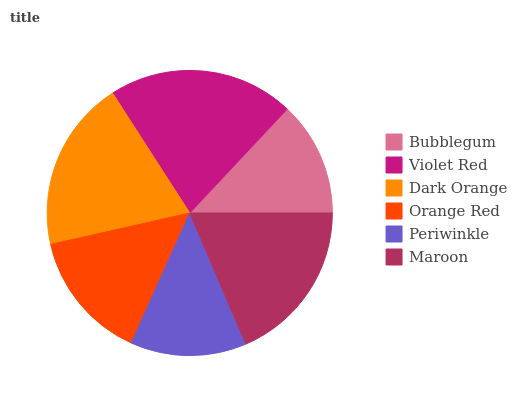Is Bubblegum the minimum?
Answer yes or no. Yes. Is Violet Red the maximum?
Answer yes or no. Yes. Is Dark Orange the minimum?
Answer yes or no. No. Is Dark Orange the maximum?
Answer yes or no. No. Is Violet Red greater than Dark Orange?
Answer yes or no. Yes. Is Dark Orange less than Violet Red?
Answer yes or no. Yes. Is Dark Orange greater than Violet Red?
Answer yes or no. No. Is Violet Red less than Dark Orange?
Answer yes or no. No. Is Maroon the high median?
Answer yes or no. Yes. Is Orange Red the low median?
Answer yes or no. Yes. Is Dark Orange the high median?
Answer yes or no. No. Is Bubblegum the low median?
Answer yes or no. No. 